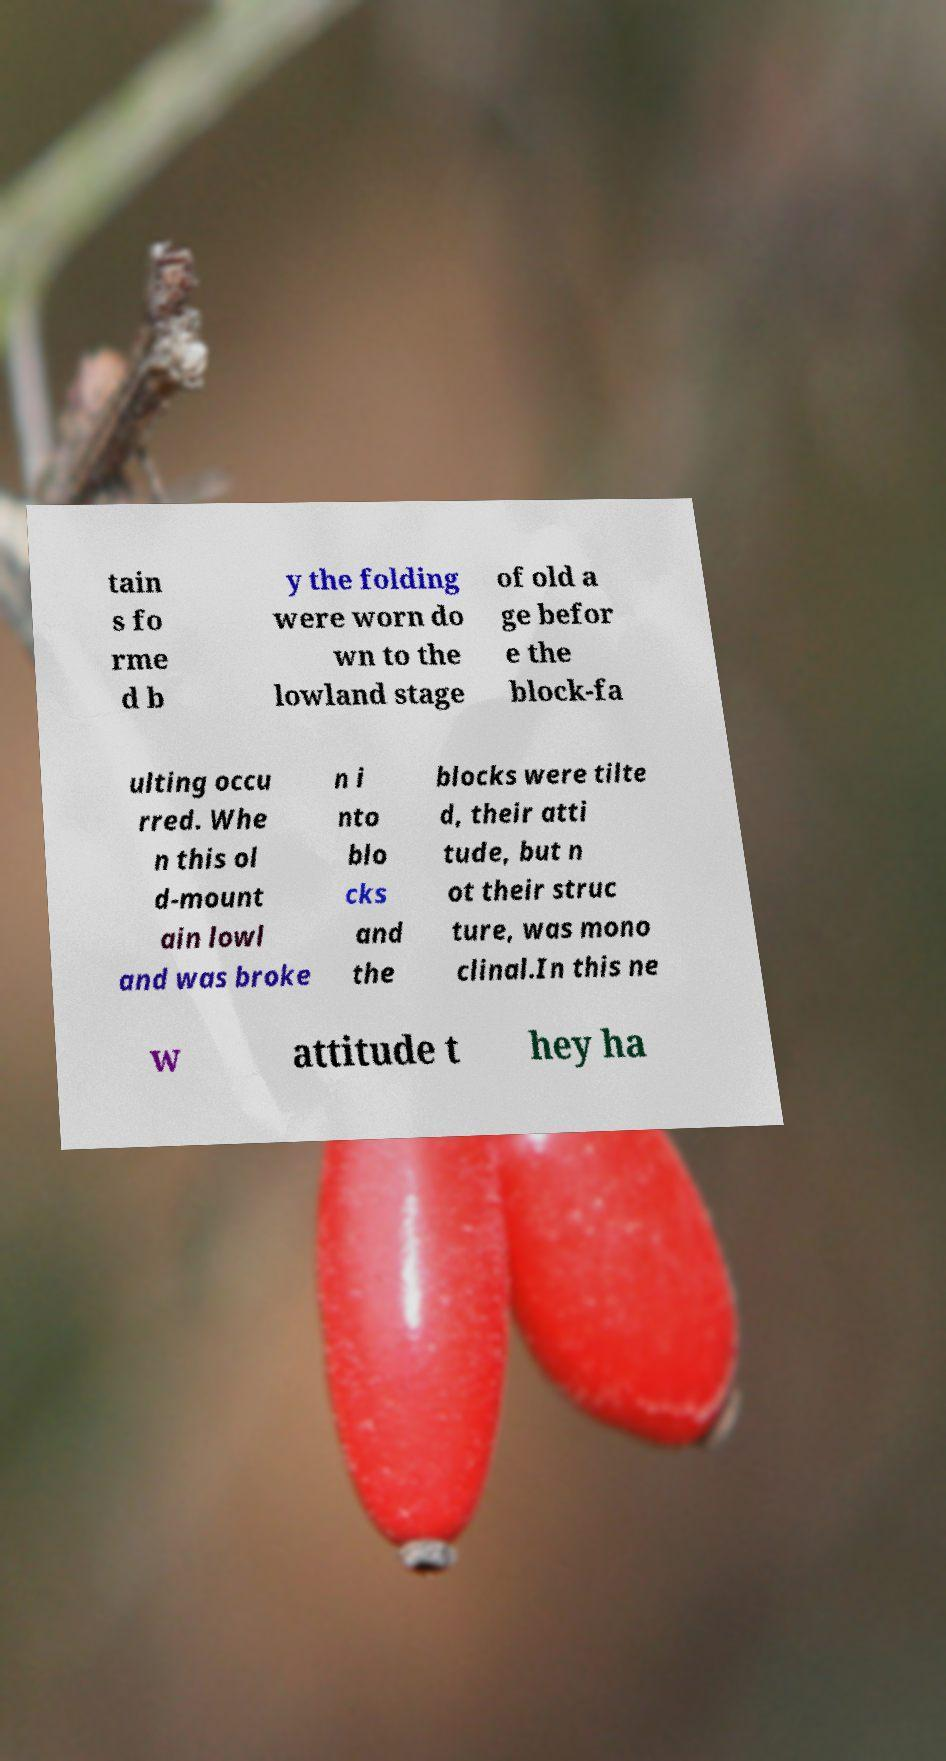For documentation purposes, I need the text within this image transcribed. Could you provide that? tain s fo rme d b y the folding were worn do wn to the lowland stage of old a ge befor e the block-fa ulting occu rred. Whe n this ol d-mount ain lowl and was broke n i nto blo cks and the blocks were tilte d, their atti tude, but n ot their struc ture, was mono clinal.In this ne w attitude t hey ha 